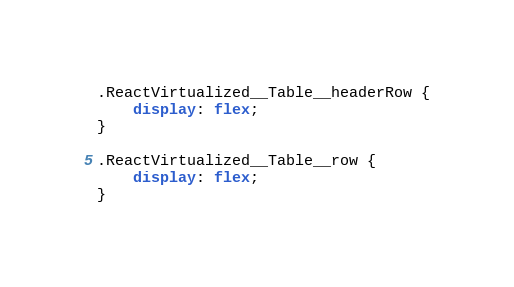Convert code to text. <code><loc_0><loc_0><loc_500><loc_500><_CSS_>.ReactVirtualized__Table__headerRow {
    display: flex;
}

.ReactVirtualized__Table__row {
    display: flex;
}
</code> 